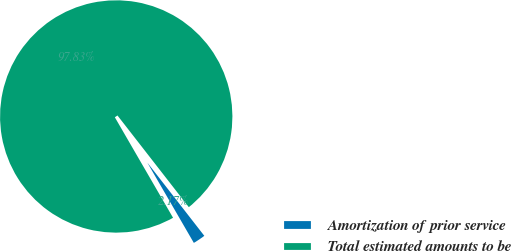<chart> <loc_0><loc_0><loc_500><loc_500><pie_chart><fcel>Amortization of prior service<fcel>Total estimated amounts to be<nl><fcel>2.17%<fcel>97.83%<nl></chart> 